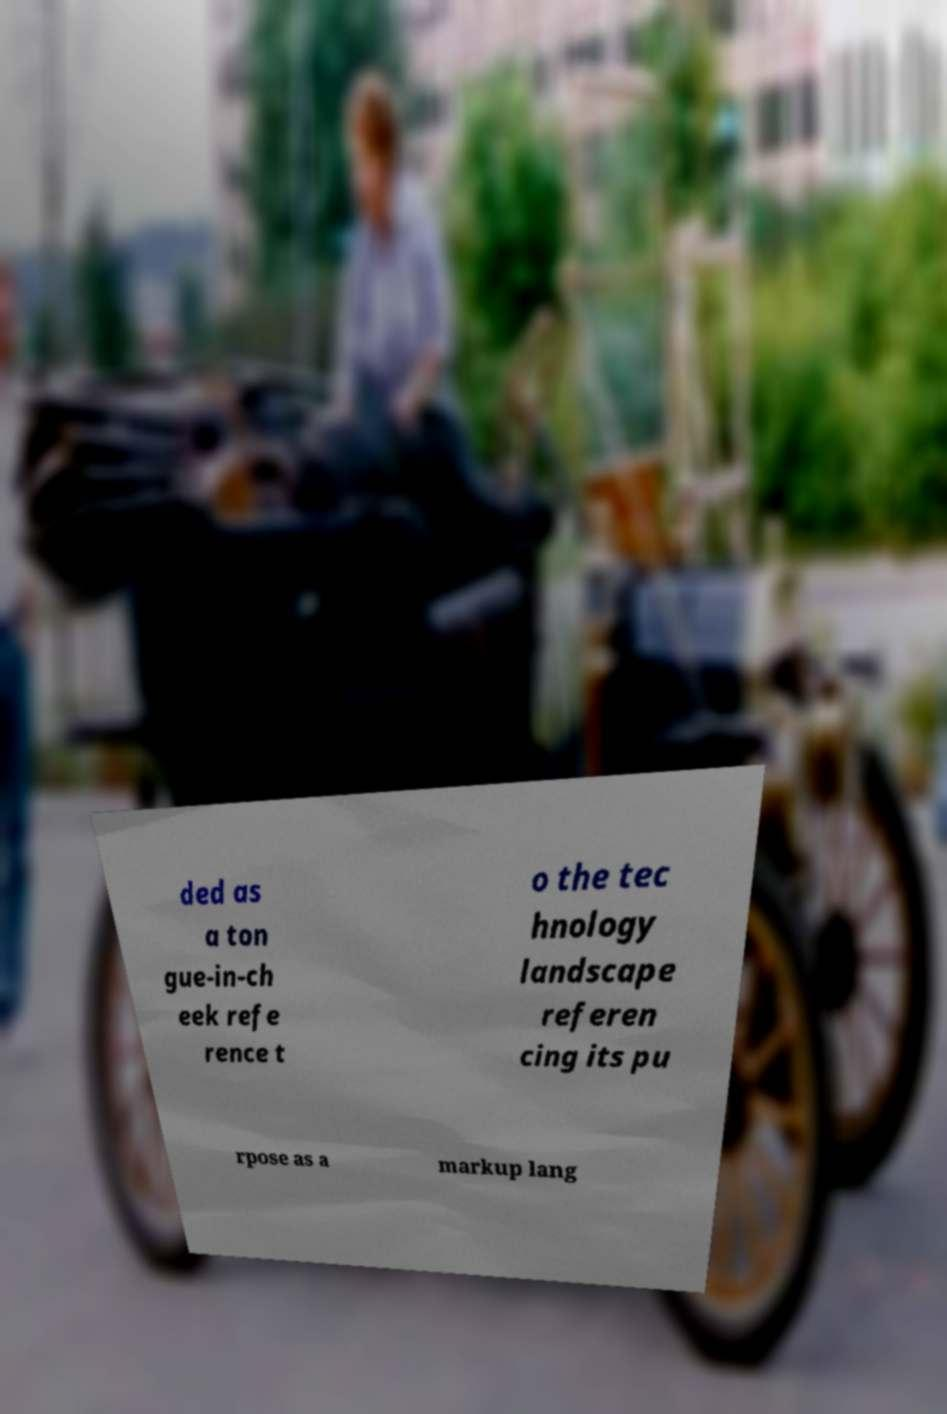Could you extract and type out the text from this image? ded as a ton gue-in-ch eek refe rence t o the tec hnology landscape referen cing its pu rpose as a markup lang 